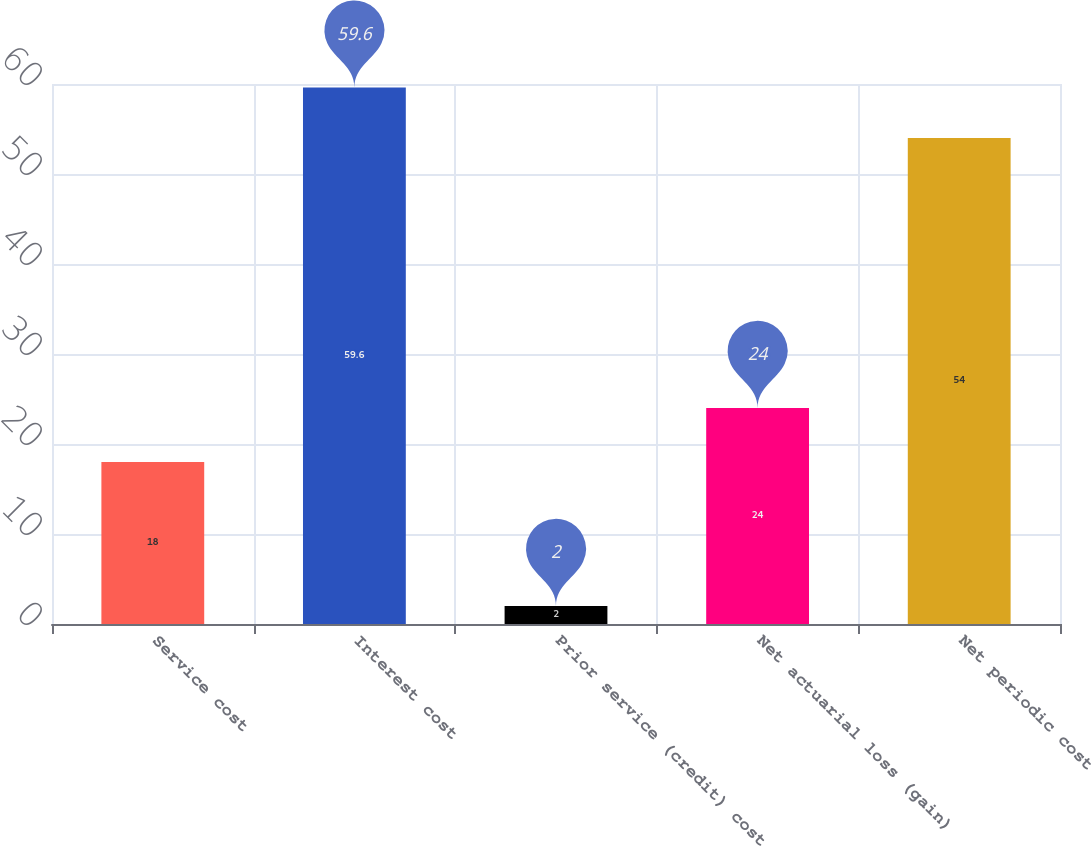Convert chart. <chart><loc_0><loc_0><loc_500><loc_500><bar_chart><fcel>Service cost<fcel>Interest cost<fcel>Prior service (credit) cost<fcel>Net actuarial loss (gain)<fcel>Net periodic cost<nl><fcel>18<fcel>59.6<fcel>2<fcel>24<fcel>54<nl></chart> 